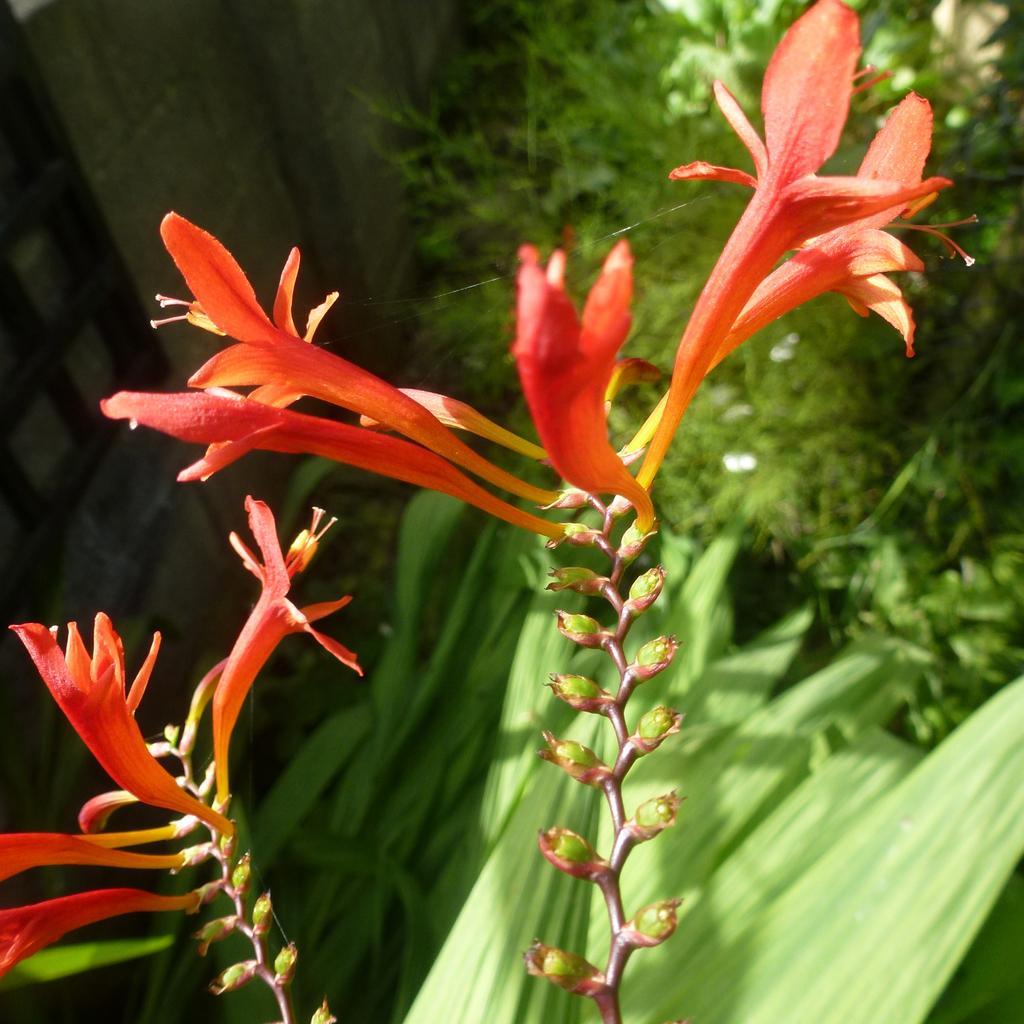Describe this image in one or two sentences. In this picture, we can see some plants, and some flowers. 